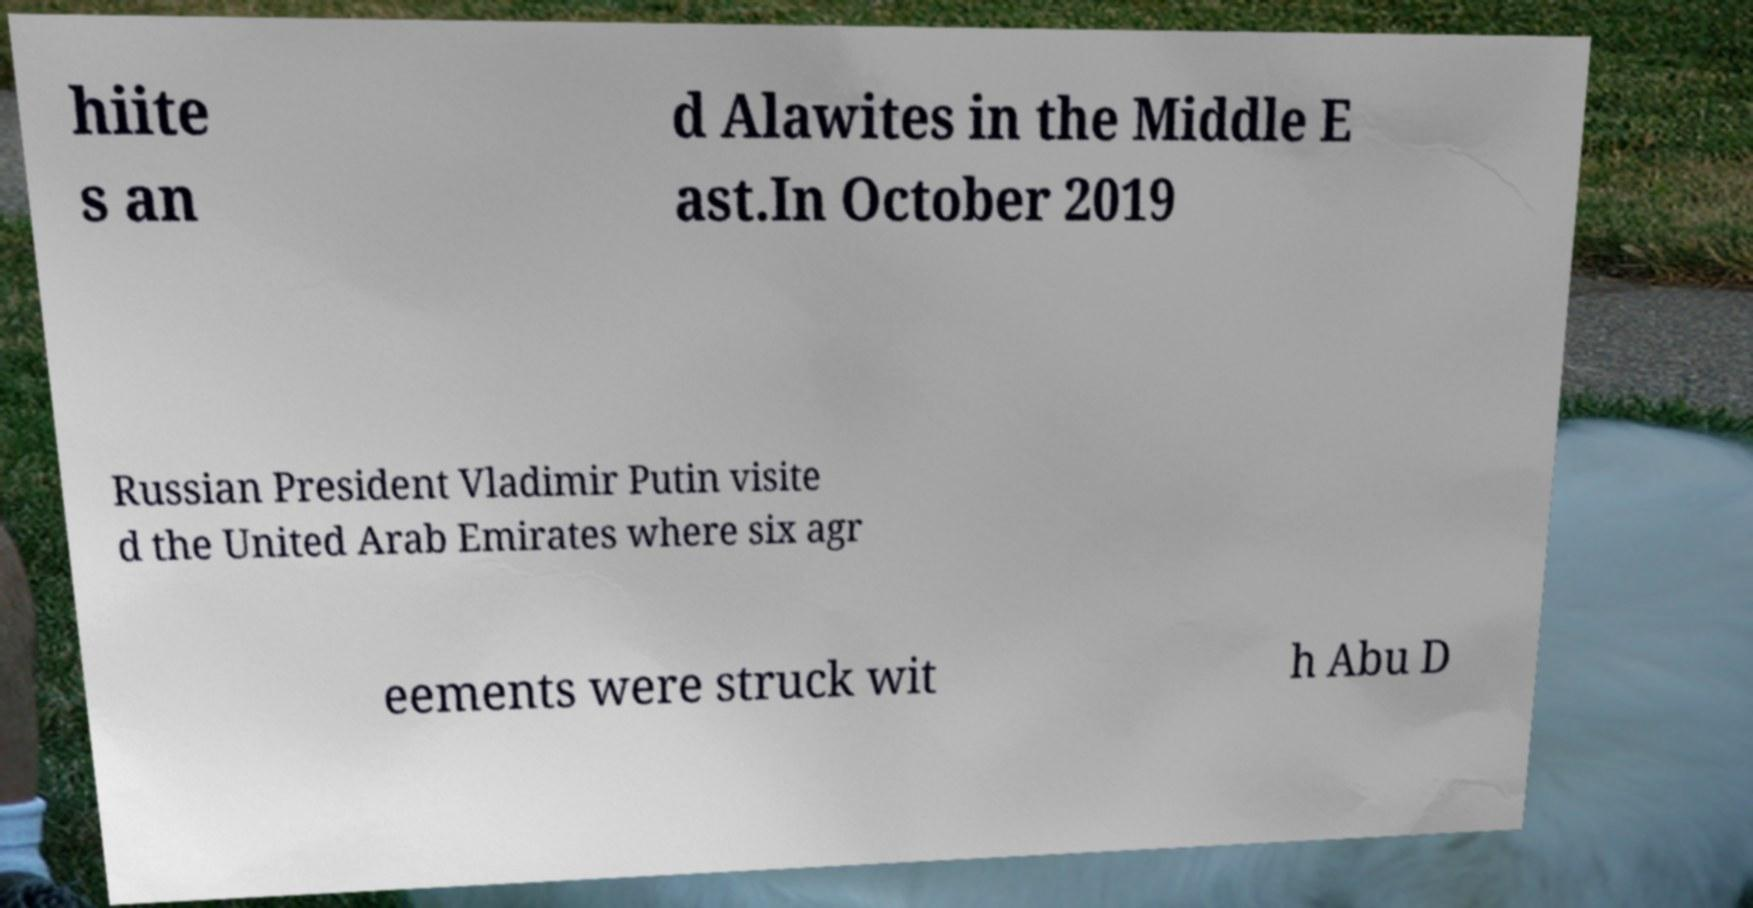Can you read and provide the text displayed in the image?This photo seems to have some interesting text. Can you extract and type it out for me? hiite s an d Alawites in the Middle E ast.In October 2019 Russian President Vladimir Putin visite d the United Arab Emirates where six agr eements were struck wit h Abu D 